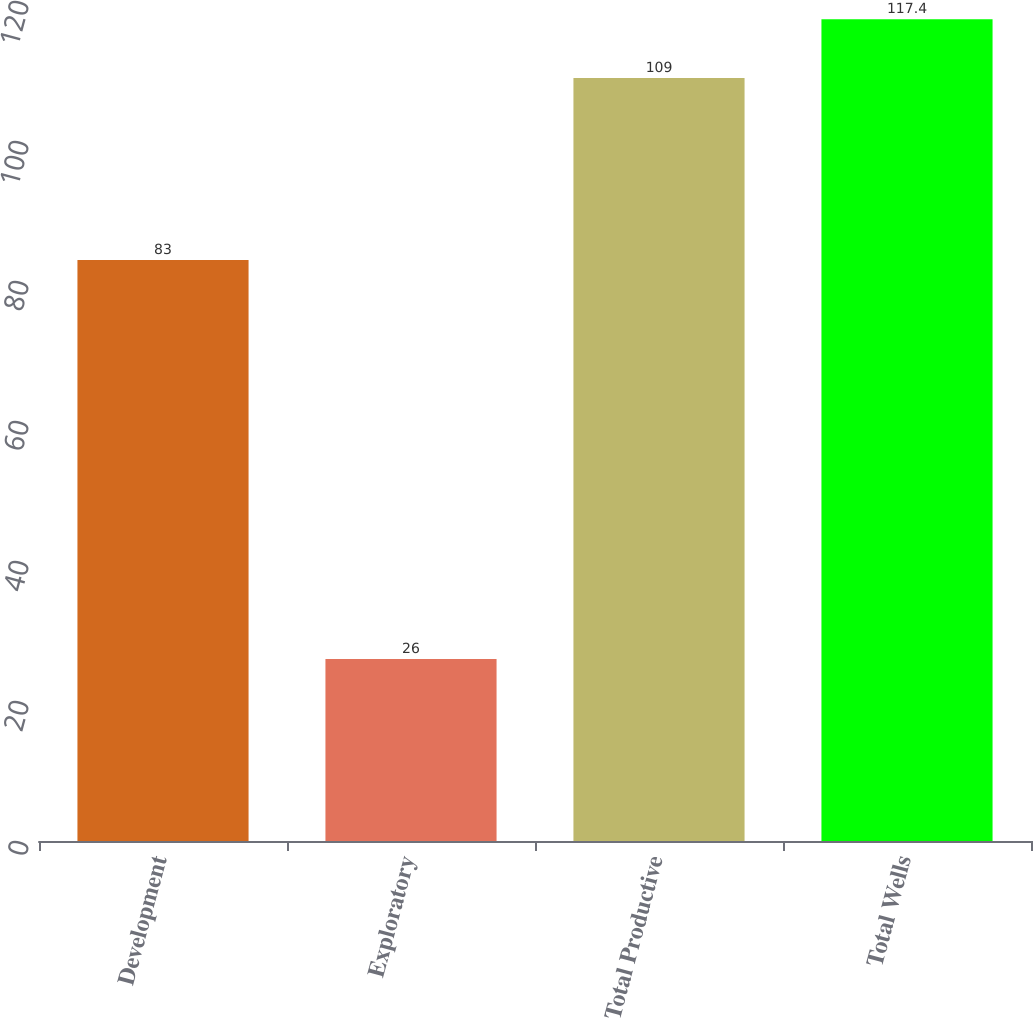Convert chart. <chart><loc_0><loc_0><loc_500><loc_500><bar_chart><fcel>Development<fcel>Exploratory<fcel>Total Productive<fcel>Total Wells<nl><fcel>83<fcel>26<fcel>109<fcel>117.4<nl></chart> 